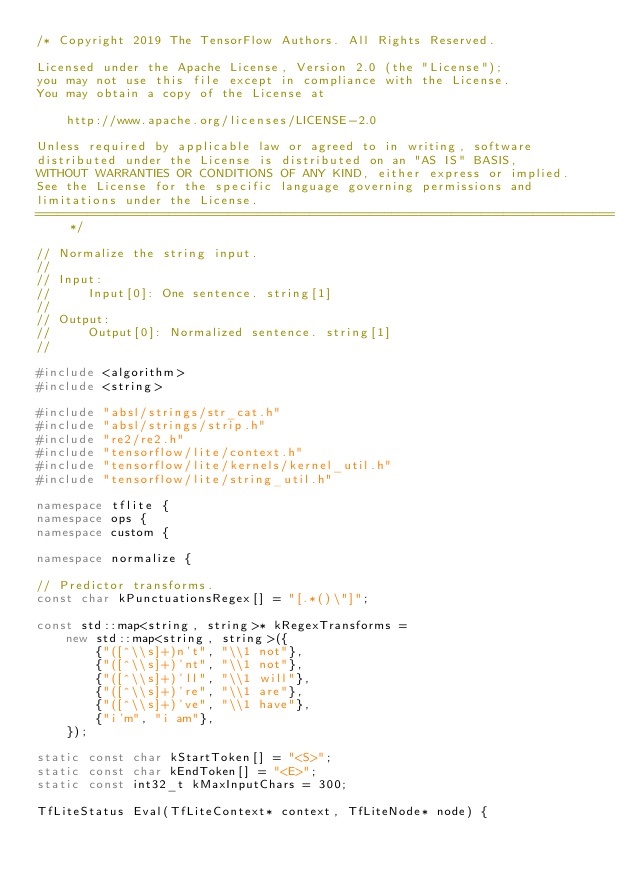<code> <loc_0><loc_0><loc_500><loc_500><_C++_>/* Copyright 2019 The TensorFlow Authors. All Rights Reserved.

Licensed under the Apache License, Version 2.0 (the "License");
you may not use this file except in compliance with the License.
You may obtain a copy of the License at

    http://www.apache.org/licenses/LICENSE-2.0

Unless required by applicable law or agreed to in writing, software
distributed under the License is distributed on an "AS IS" BASIS,
WITHOUT WARRANTIES OR CONDITIONS OF ANY KIND, either express or implied.
See the License for the specific language governing permissions and
limitations under the License.
==============================================================================*/

// Normalize the string input.
//
// Input:
//     Input[0]: One sentence. string[1]
//
// Output:
//     Output[0]: Normalized sentence. string[1]
//

#include <algorithm>
#include <string>

#include "absl/strings/str_cat.h"
#include "absl/strings/strip.h"
#include "re2/re2.h"
#include "tensorflow/lite/context.h"
#include "tensorflow/lite/kernels/kernel_util.h"
#include "tensorflow/lite/string_util.h"

namespace tflite {
namespace ops {
namespace custom {

namespace normalize {

// Predictor transforms.
const char kPunctuationsRegex[] = "[.*()\"]";

const std::map<string, string>* kRegexTransforms =
    new std::map<string, string>({
        {"([^\\s]+)n't", "\\1 not"},
        {"([^\\s]+)'nt", "\\1 not"},
        {"([^\\s]+)'ll", "\\1 will"},
        {"([^\\s]+)'re", "\\1 are"},
        {"([^\\s]+)'ve", "\\1 have"},
        {"i'm", "i am"},
    });

static const char kStartToken[] = "<S>";
static const char kEndToken[] = "<E>";
static const int32_t kMaxInputChars = 300;

TfLiteStatus Eval(TfLiteContext* context, TfLiteNode* node) {</code> 